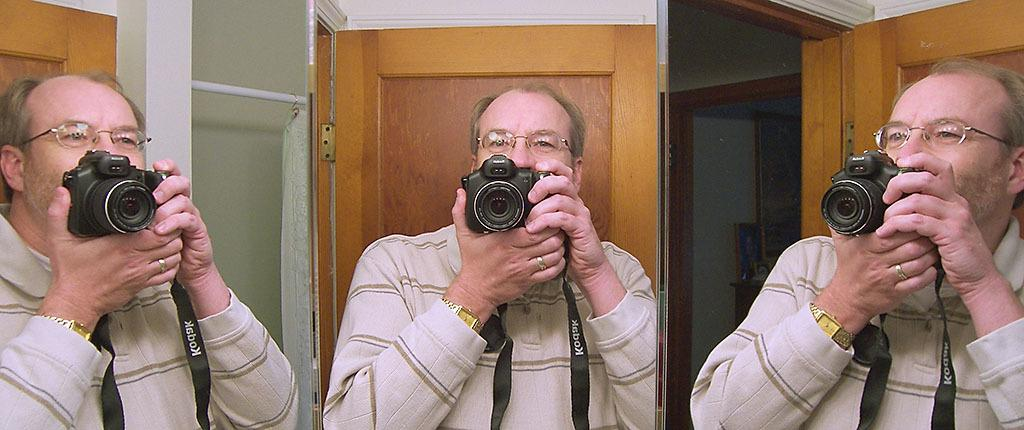How many people are in the image? There are three persons in the image. What are the persons doing in the image? The persons are standing and holding a camera in both hands. What type of store can be seen in the background of the image? There is no store visible in the image; it only shows three persons holding a camera. 